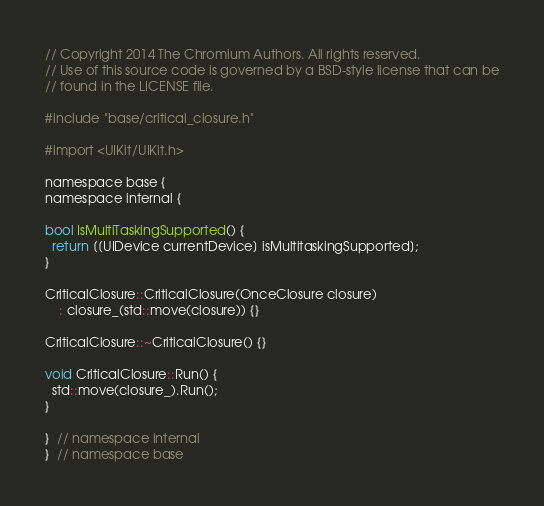Convert code to text. <code><loc_0><loc_0><loc_500><loc_500><_ObjectiveC_>// Copyright 2014 The Chromium Authors. All rights reserved.
// Use of this source code is governed by a BSD-style license that can be
// found in the LICENSE file.

#include "base/critical_closure.h"

#import <UIKit/UIKit.h>

namespace base {
namespace internal {

bool IsMultiTaskingSupported() {
  return [[UIDevice currentDevice] isMultitaskingSupported];
}

CriticalClosure::CriticalClosure(OnceClosure closure)
    : closure_(std::move(closure)) {}

CriticalClosure::~CriticalClosure() {}

void CriticalClosure::Run() {
  std::move(closure_).Run();
}

}  // namespace internal
}  // namespace base
</code> 